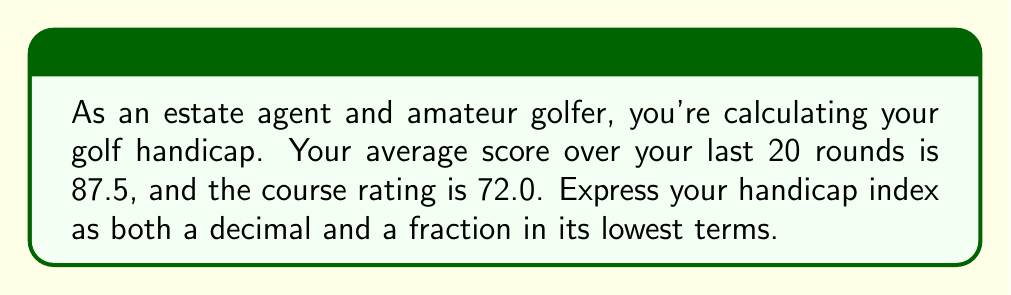What is the answer to this math problem? To solve this problem, we'll follow these steps:

1) The golf handicap index is calculated using the formula:
   $$ \text{Handicap Index} = (\text{Average Score} - \text{Course Rating}) \times 0.96 $$

2) Let's plug in our values:
   $$ \text{Handicap Index} = (87.5 - 72.0) \times 0.96 $$

3) First, calculate the difference inside the parentheses:
   $$ \text{Handicap Index} = 15.5 \times 0.96 $$

4) Now multiply:
   $$ \text{Handicap Index} = 14.88 $$

5) This is our handicap index as a decimal.

6) To convert this to a fraction, we need to express 14.88 as a fraction over 100:
   $$ \frac{1488}{100} $$

7) To reduce this fraction to its lowest terms, we need to find the greatest common divisor (GCD) of 1488 and 100. The GCD is 4.

8) Divide both the numerator and denominator by 4:
   $$ \frac{1488 \div 4}{100 \div 4} = \frac{372}{25} $$

Therefore, the handicap index as a fraction in its lowest terms is $\frac{372}{25}$.
Answer: Decimal: 14.88
Fraction: $\frac{372}{25}$ 